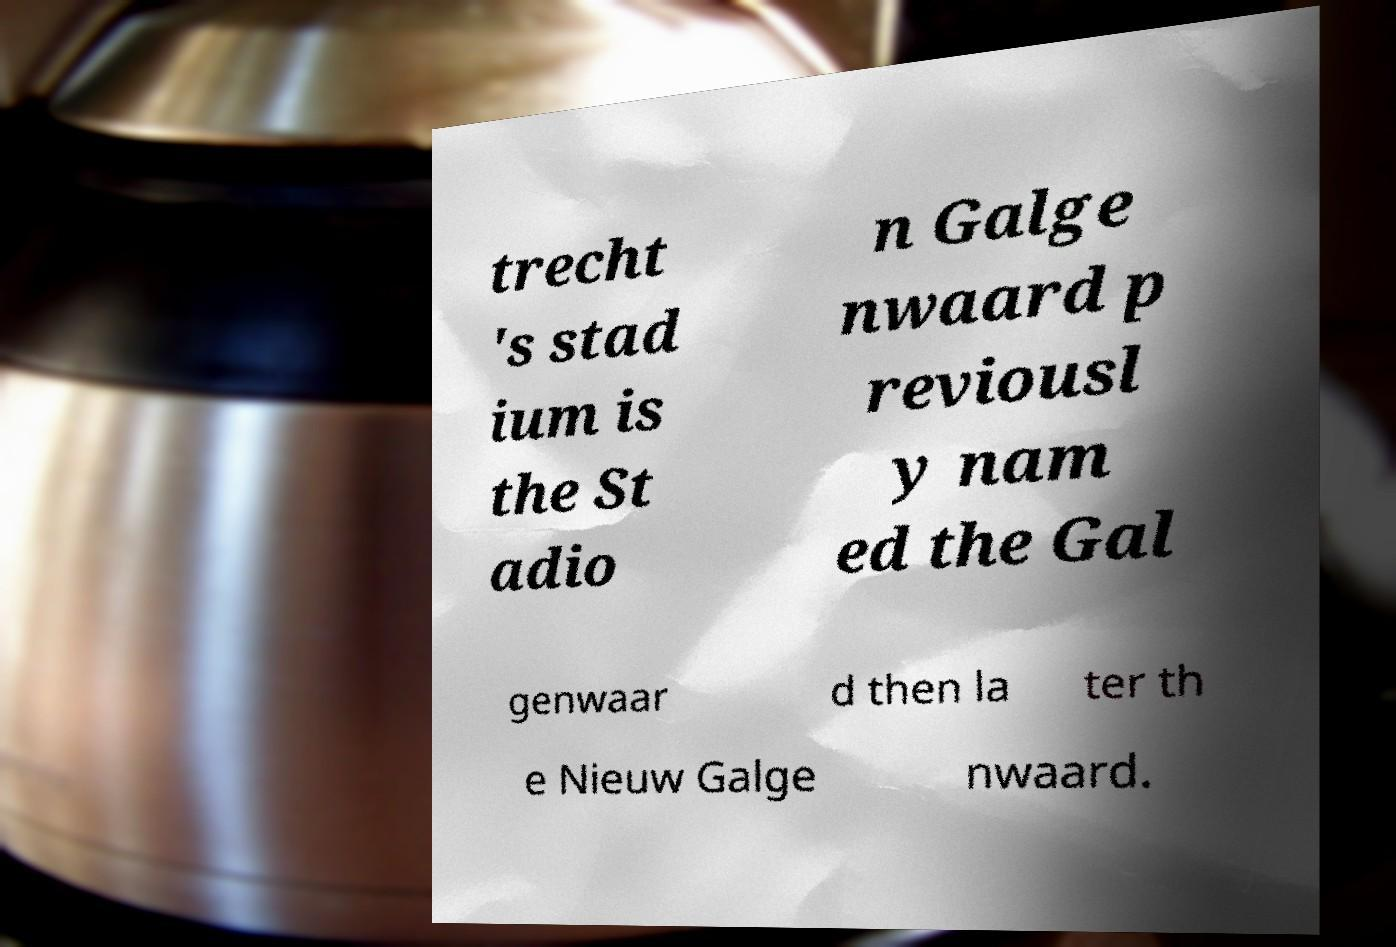What messages or text are displayed in this image? I need them in a readable, typed format. trecht 's stad ium is the St adio n Galge nwaard p reviousl y nam ed the Gal genwaar d then la ter th e Nieuw Galge nwaard. 